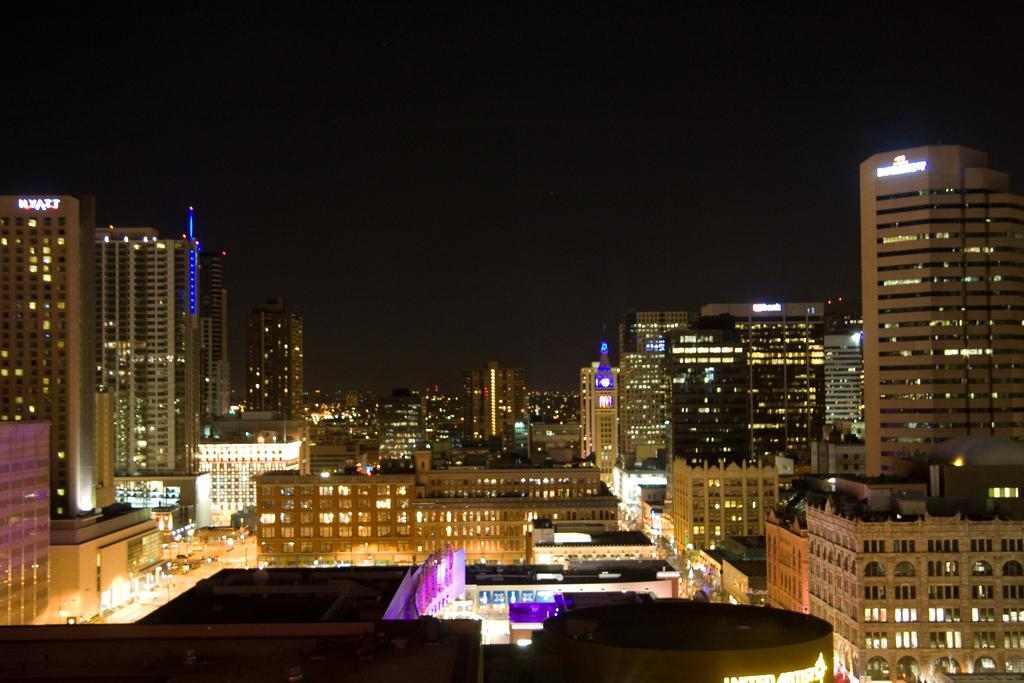What type of structures are present in the image? There are buildings in the image. What feature do the buildings have? The buildings have windows. What can be seen illuminated in the image? There are lights visible in the image. What type of text is present in the image? There is LED text in the image. How would you describe the sky in the image? The sky is dark in the image. How many books are stacked on the sock in the image? There are no books or socks present in the image. 